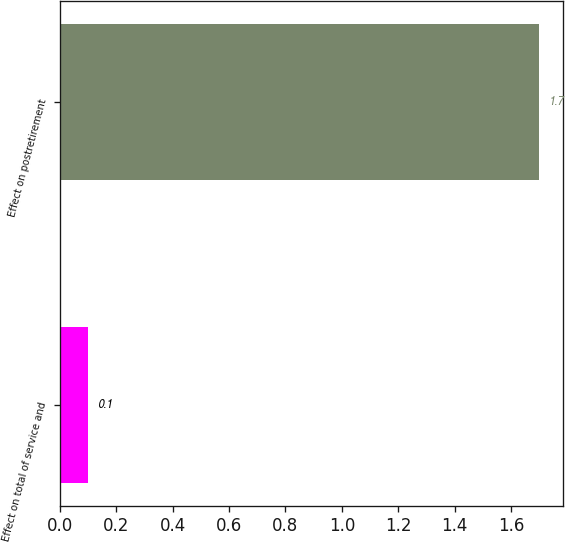Convert chart. <chart><loc_0><loc_0><loc_500><loc_500><bar_chart><fcel>Effect on total of service and<fcel>Effect on postretirement<nl><fcel>0.1<fcel>1.7<nl></chart> 